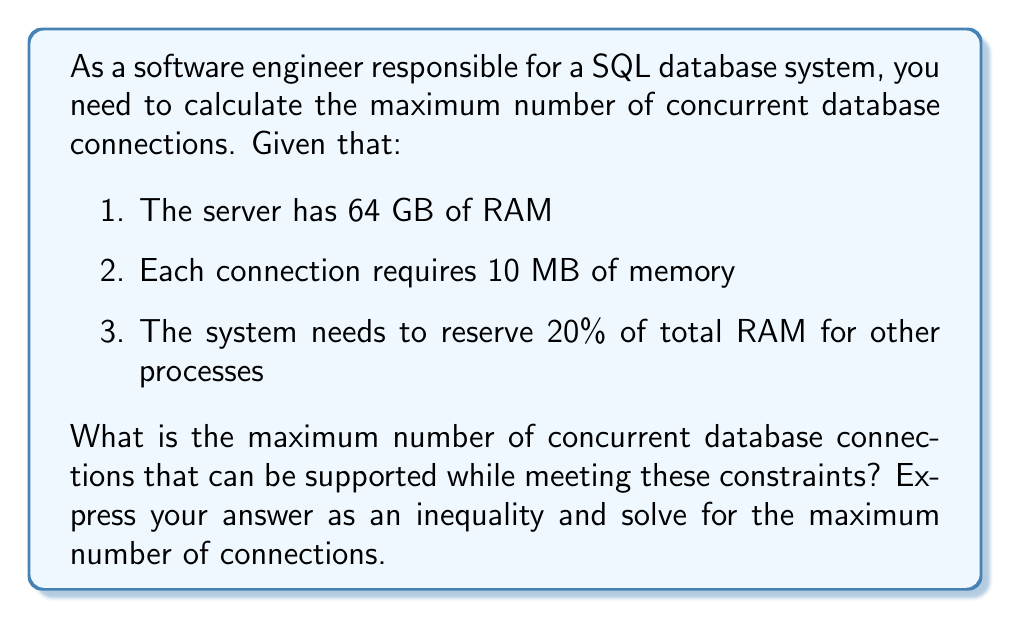Can you solve this math problem? Let's approach this step-by-step:

1. Define variables:
   Let $x$ be the number of concurrent database connections.

2. Convert units:
   64 GB = 64 * 1024 MB = 65,536 MB

3. Set up the inequality:
   The total memory used by connections plus the reserved memory should be less than or equal to the total available RAM.

   $$(10x \text{ MB}) + (0.2 * 65,536 \text{ MB}) \leq 65,536 \text{ MB}$$

4. Simplify the inequality:
   $$10x + 13,107.2 \leq 65,536$$

5. Subtract 13,107.2 from both sides:
   $$10x \leq 52,428.8$$

6. Divide both sides by 10:
   $$x \leq 5,242.88$$

7. Since we can't have a fractional number of connections, we round down to the nearest whole number:
   $$x \leq 5,242$$

Therefore, the maximum number of concurrent database connections is 5,242.
Answer: The maximum number of concurrent database connections is 5,242, satisfying the inequality $x \leq 5,242$. 